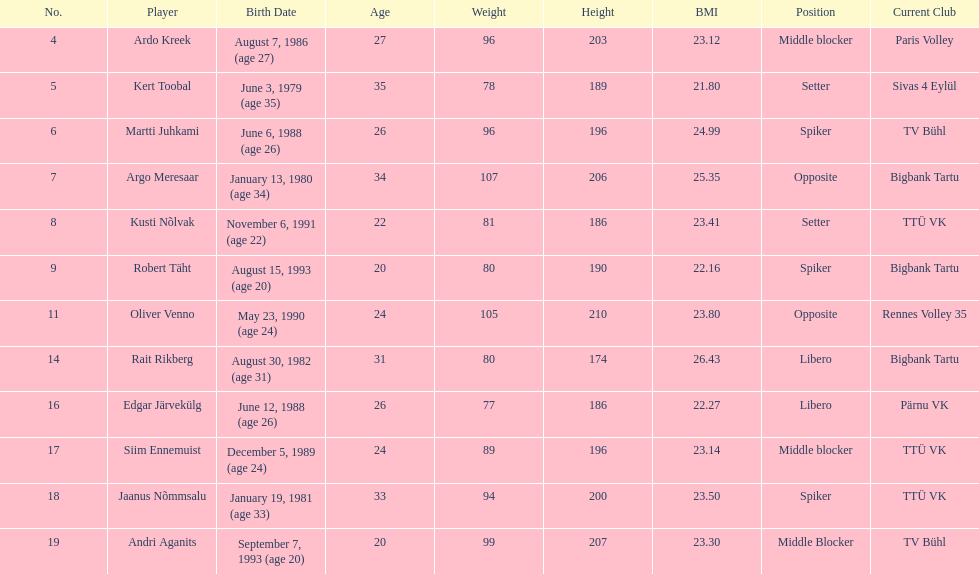How many players were born before 1988? 5. 